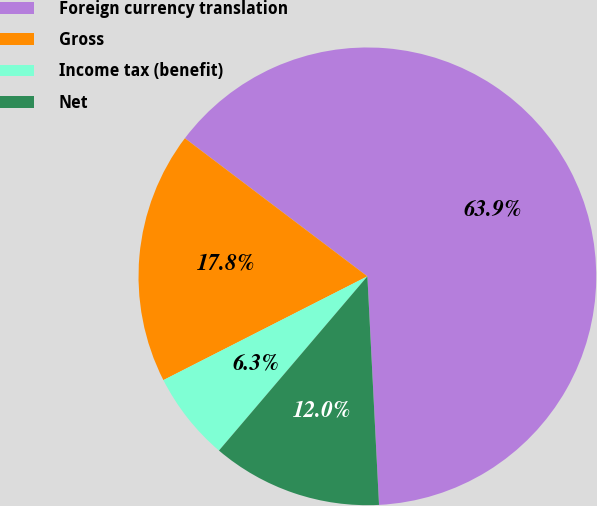Convert chart to OTSL. <chart><loc_0><loc_0><loc_500><loc_500><pie_chart><fcel>Foreign currency translation<fcel>Gross<fcel>Income tax (benefit)<fcel>Net<nl><fcel>63.88%<fcel>17.8%<fcel>6.28%<fcel>12.04%<nl></chart> 